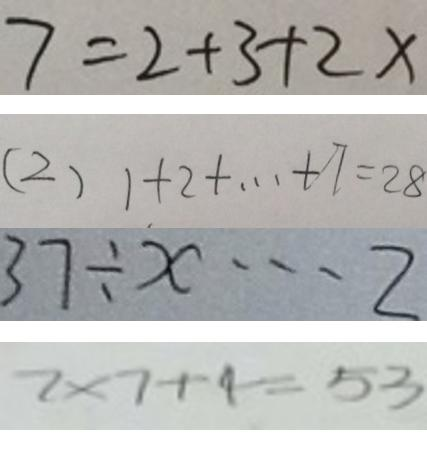<formula> <loc_0><loc_0><loc_500><loc_500>7 = 2 + 3 + 2 x 
 ( 2 ) 1 + 2 + \cdots + 7 = 2 8 
 3 7 \div x \cdots 2 
 7 \times 7 + 4 = 5 3</formula> 